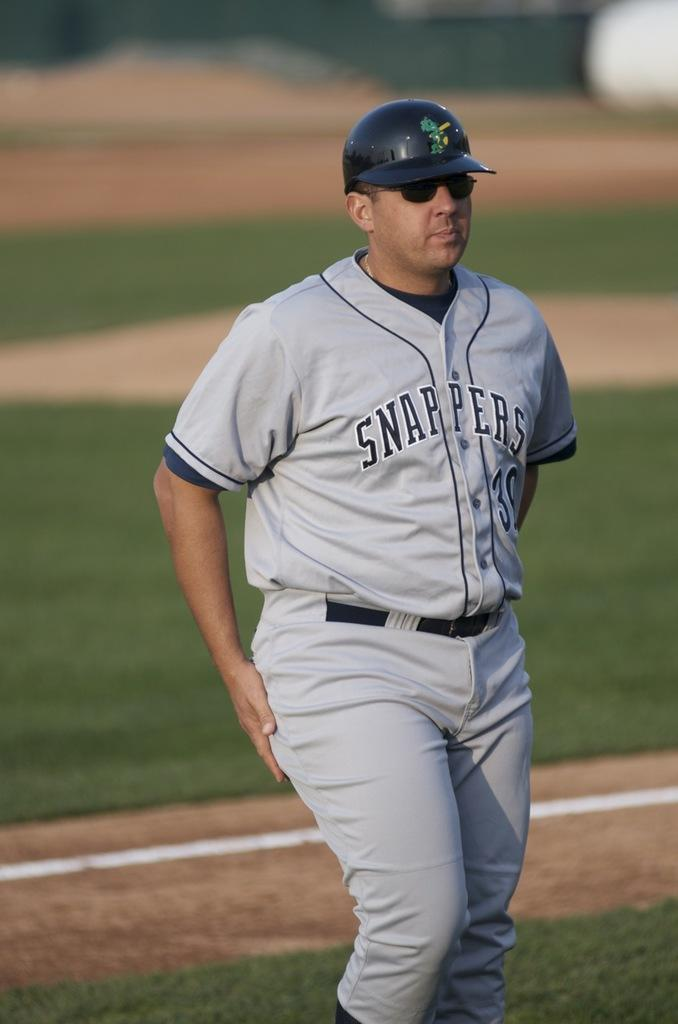<image>
Provide a brief description of the given image. A man on a baseball field in a Snappers baseball uniform and cap. 